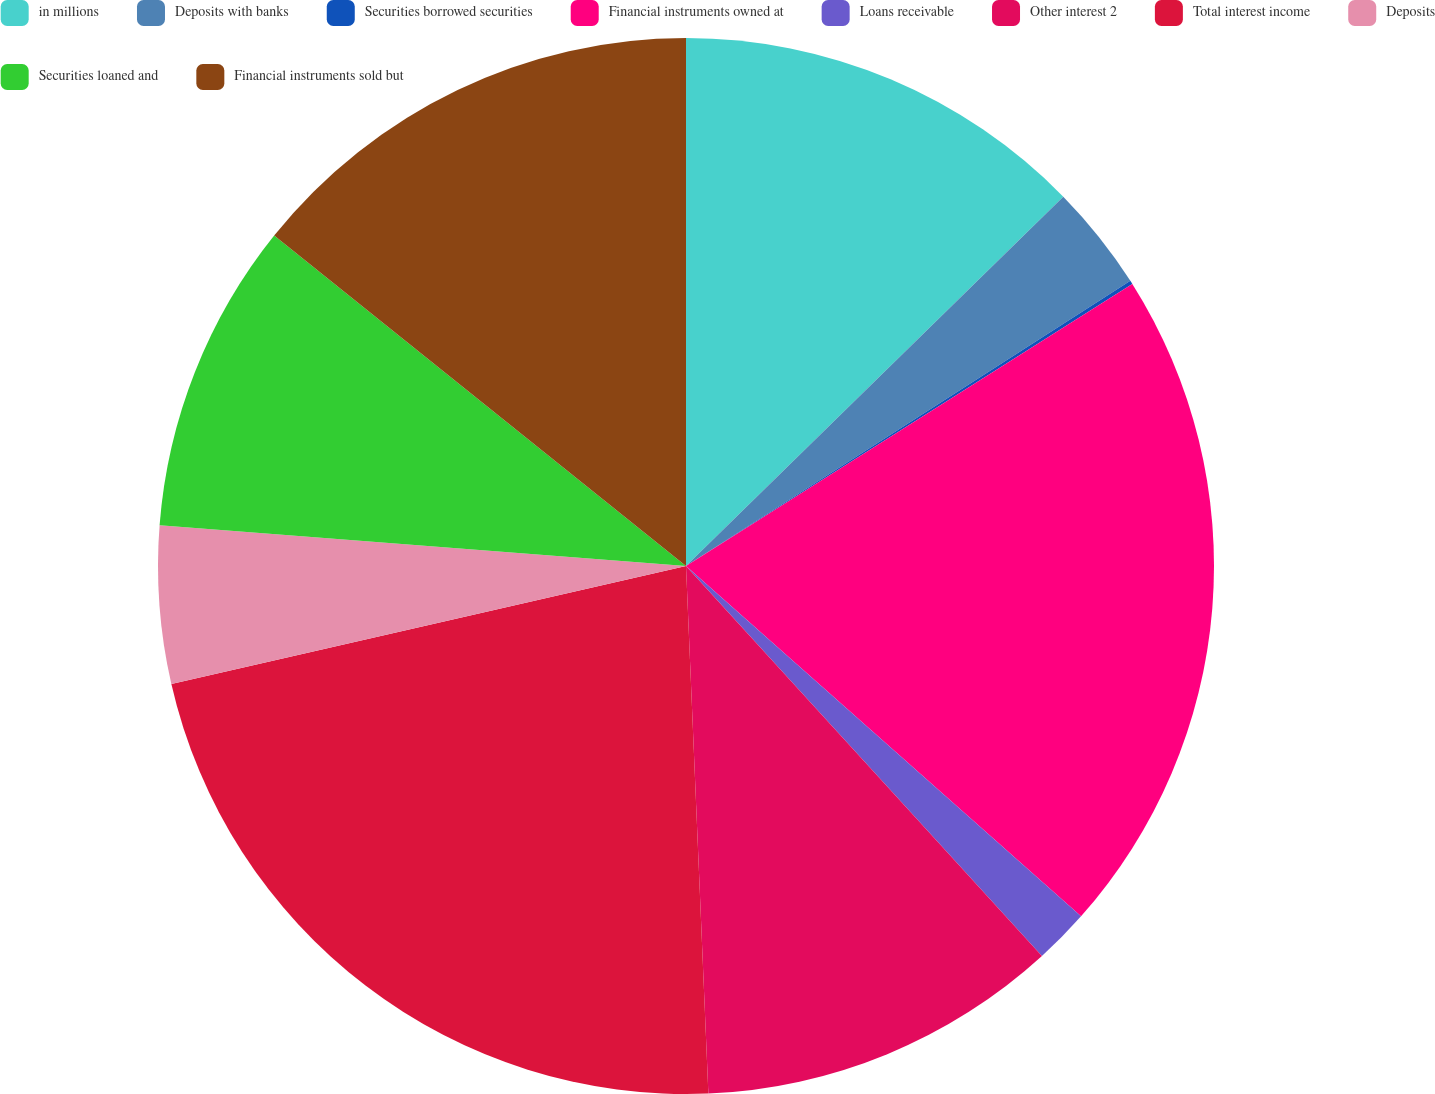Convert chart to OTSL. <chart><loc_0><loc_0><loc_500><loc_500><pie_chart><fcel>in millions<fcel>Deposits with banks<fcel>Securities borrowed securities<fcel>Financial instruments owned at<fcel>Loans receivable<fcel>Other interest 2<fcel>Total interest income<fcel>Deposits<fcel>Securities loaned and<fcel>Financial instruments sold but<nl><fcel>12.67%<fcel>3.25%<fcel>0.11%<fcel>20.52%<fcel>1.68%<fcel>11.1%<fcel>22.09%<fcel>4.82%<fcel>9.53%<fcel>14.24%<nl></chart> 